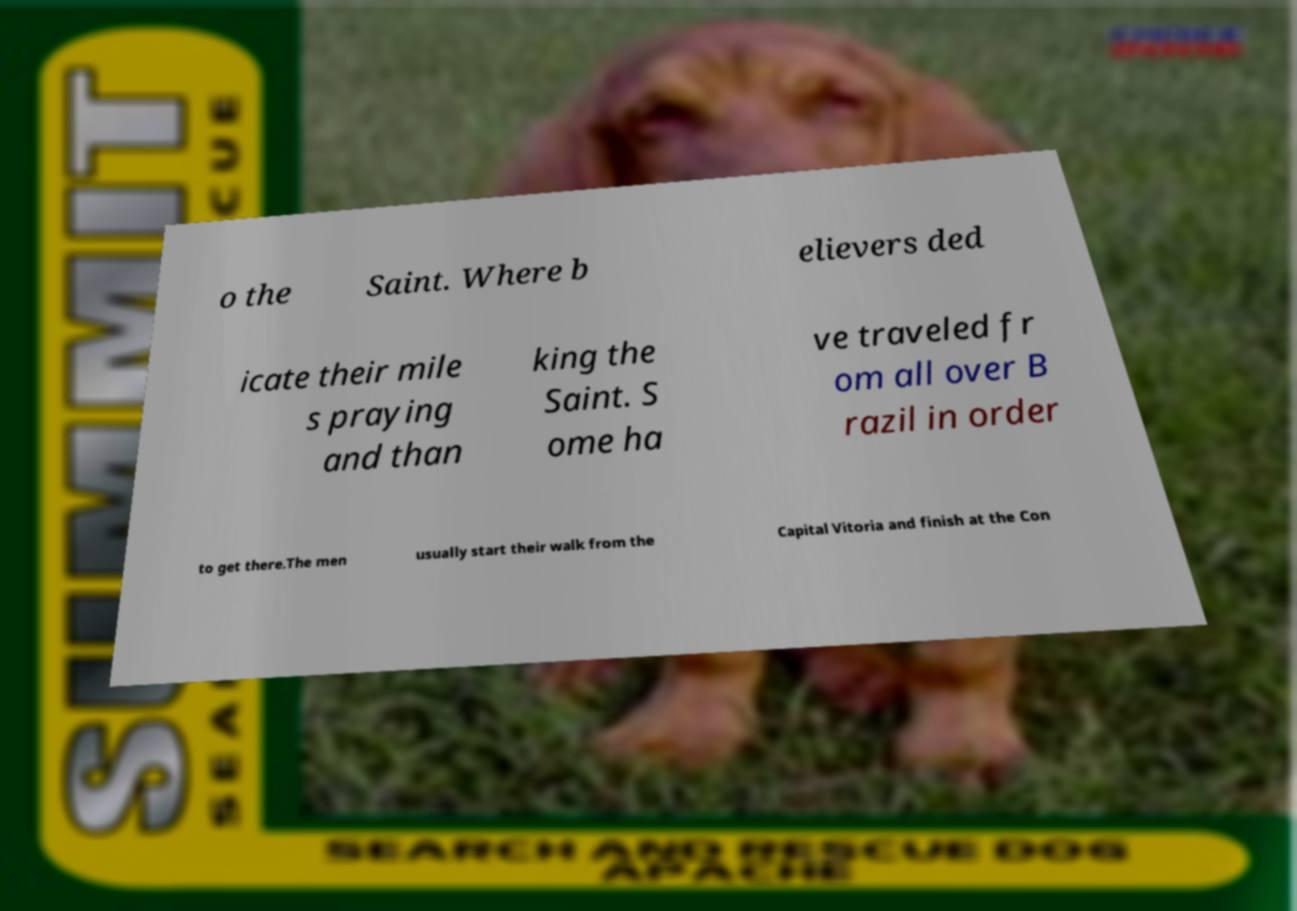Can you read and provide the text displayed in the image?This photo seems to have some interesting text. Can you extract and type it out for me? o the Saint. Where b elievers ded icate their mile s praying and than king the Saint. S ome ha ve traveled fr om all over B razil in order to get there.The men usually start their walk from the Capital Vitoria and finish at the Con 